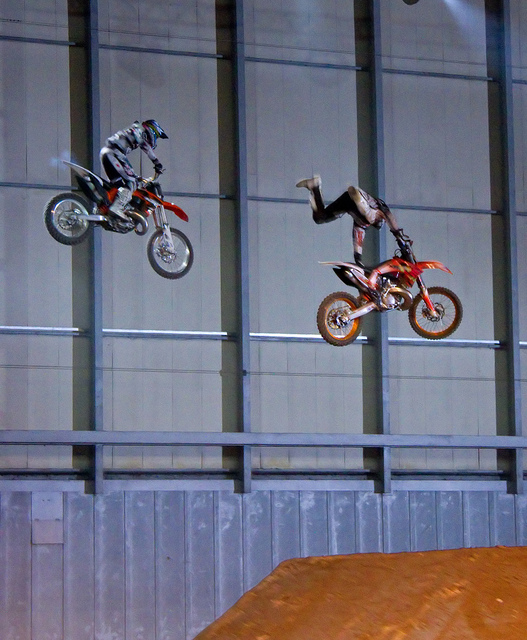Are the motorcycles the same model? It's not possible to determine with certainty from this image alone if they are the exact same model, but both motorcycles appear to be motocross bikes which are designed for events like this. 